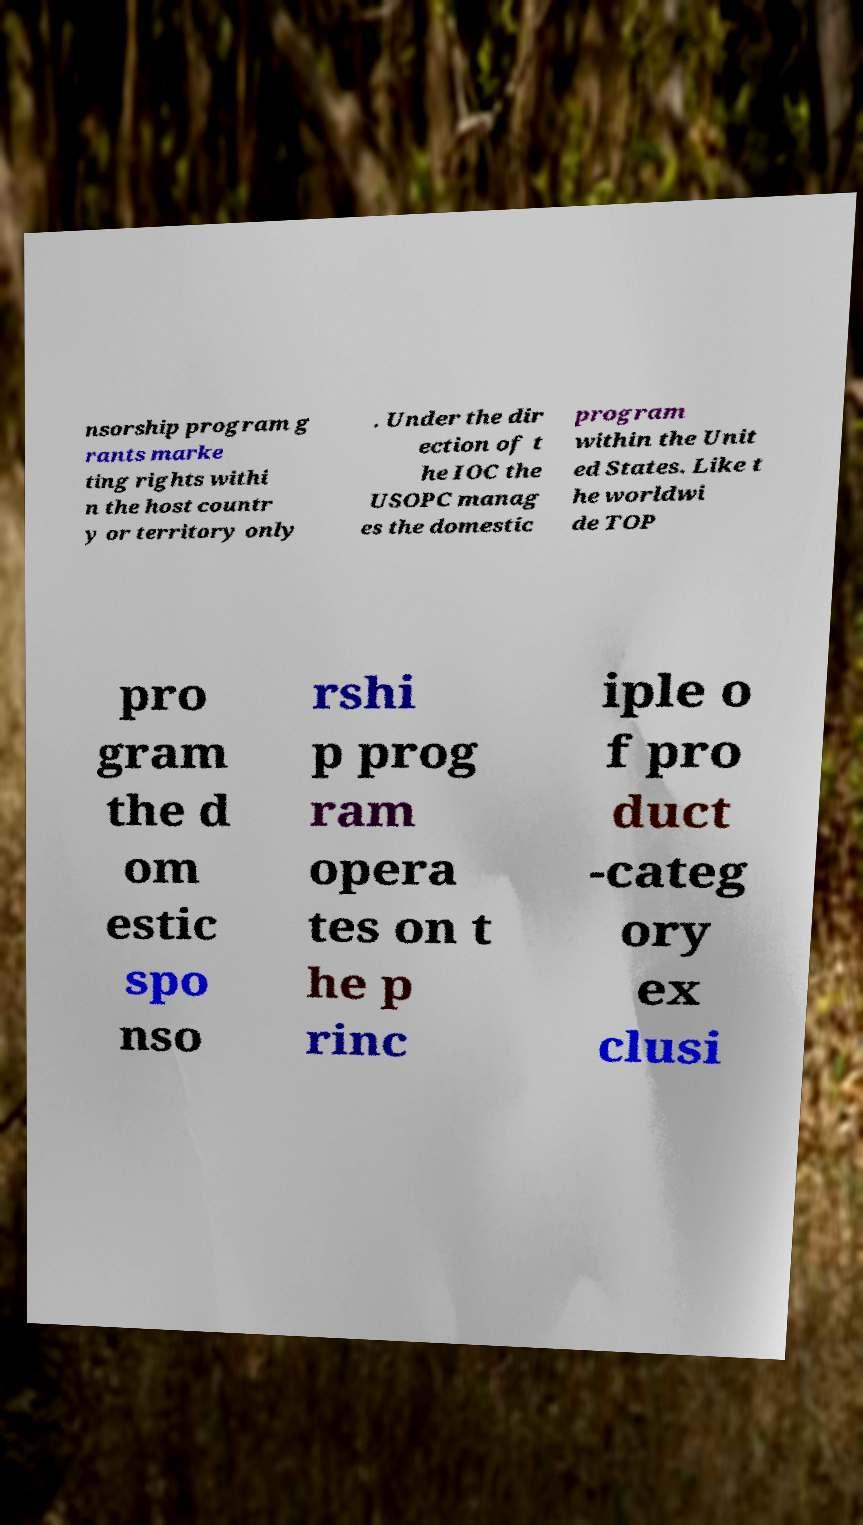Can you accurately transcribe the text from the provided image for me? nsorship program g rants marke ting rights withi n the host countr y or territory only . Under the dir ection of t he IOC the USOPC manag es the domestic program within the Unit ed States. Like t he worldwi de TOP pro gram the d om estic spo nso rshi p prog ram opera tes on t he p rinc iple o f pro duct -categ ory ex clusi 